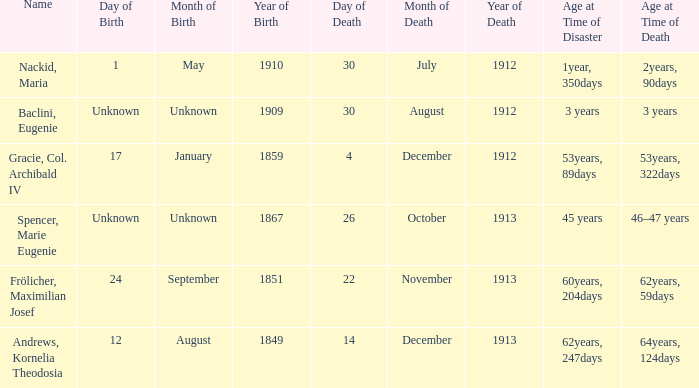When did the person born 24 September 1851 pass away? 22 November 1913. 